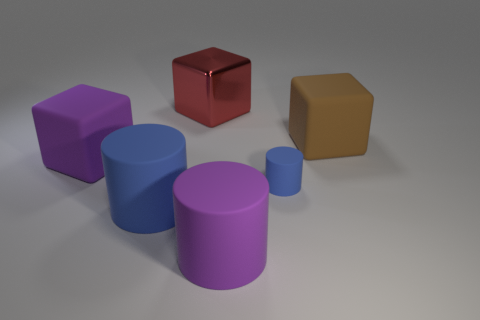There is a purple thing on the right side of the block behind the matte block that is on the right side of the tiny blue thing; what is its material?
Provide a succinct answer. Rubber. What number of other things are there of the same size as the shiny block?
Provide a short and direct response. 4. Do the tiny rubber cylinder and the large metallic block have the same color?
Keep it short and to the point. No. There is a large rubber thing that is behind the purple cube that is on the left side of the large shiny cube; how many brown rubber cubes are left of it?
Offer a very short reply. 0. There is a blue thing that is to the left of the purple cylinder in front of the tiny matte thing; what is its material?
Your answer should be very brief. Rubber. Are there any other big gray things that have the same shape as the metallic object?
Offer a terse response. No. What color is the matte cube that is the same size as the brown thing?
Your response must be concise. Purple. What number of objects are either blue cylinders that are right of the large purple cylinder or big rubber objects to the right of the red shiny cube?
Keep it short and to the point. 3. What number of objects are big brown things or small balls?
Give a very brief answer. 1. What is the size of the cube that is left of the purple matte cylinder and in front of the big red shiny block?
Offer a terse response. Large. 